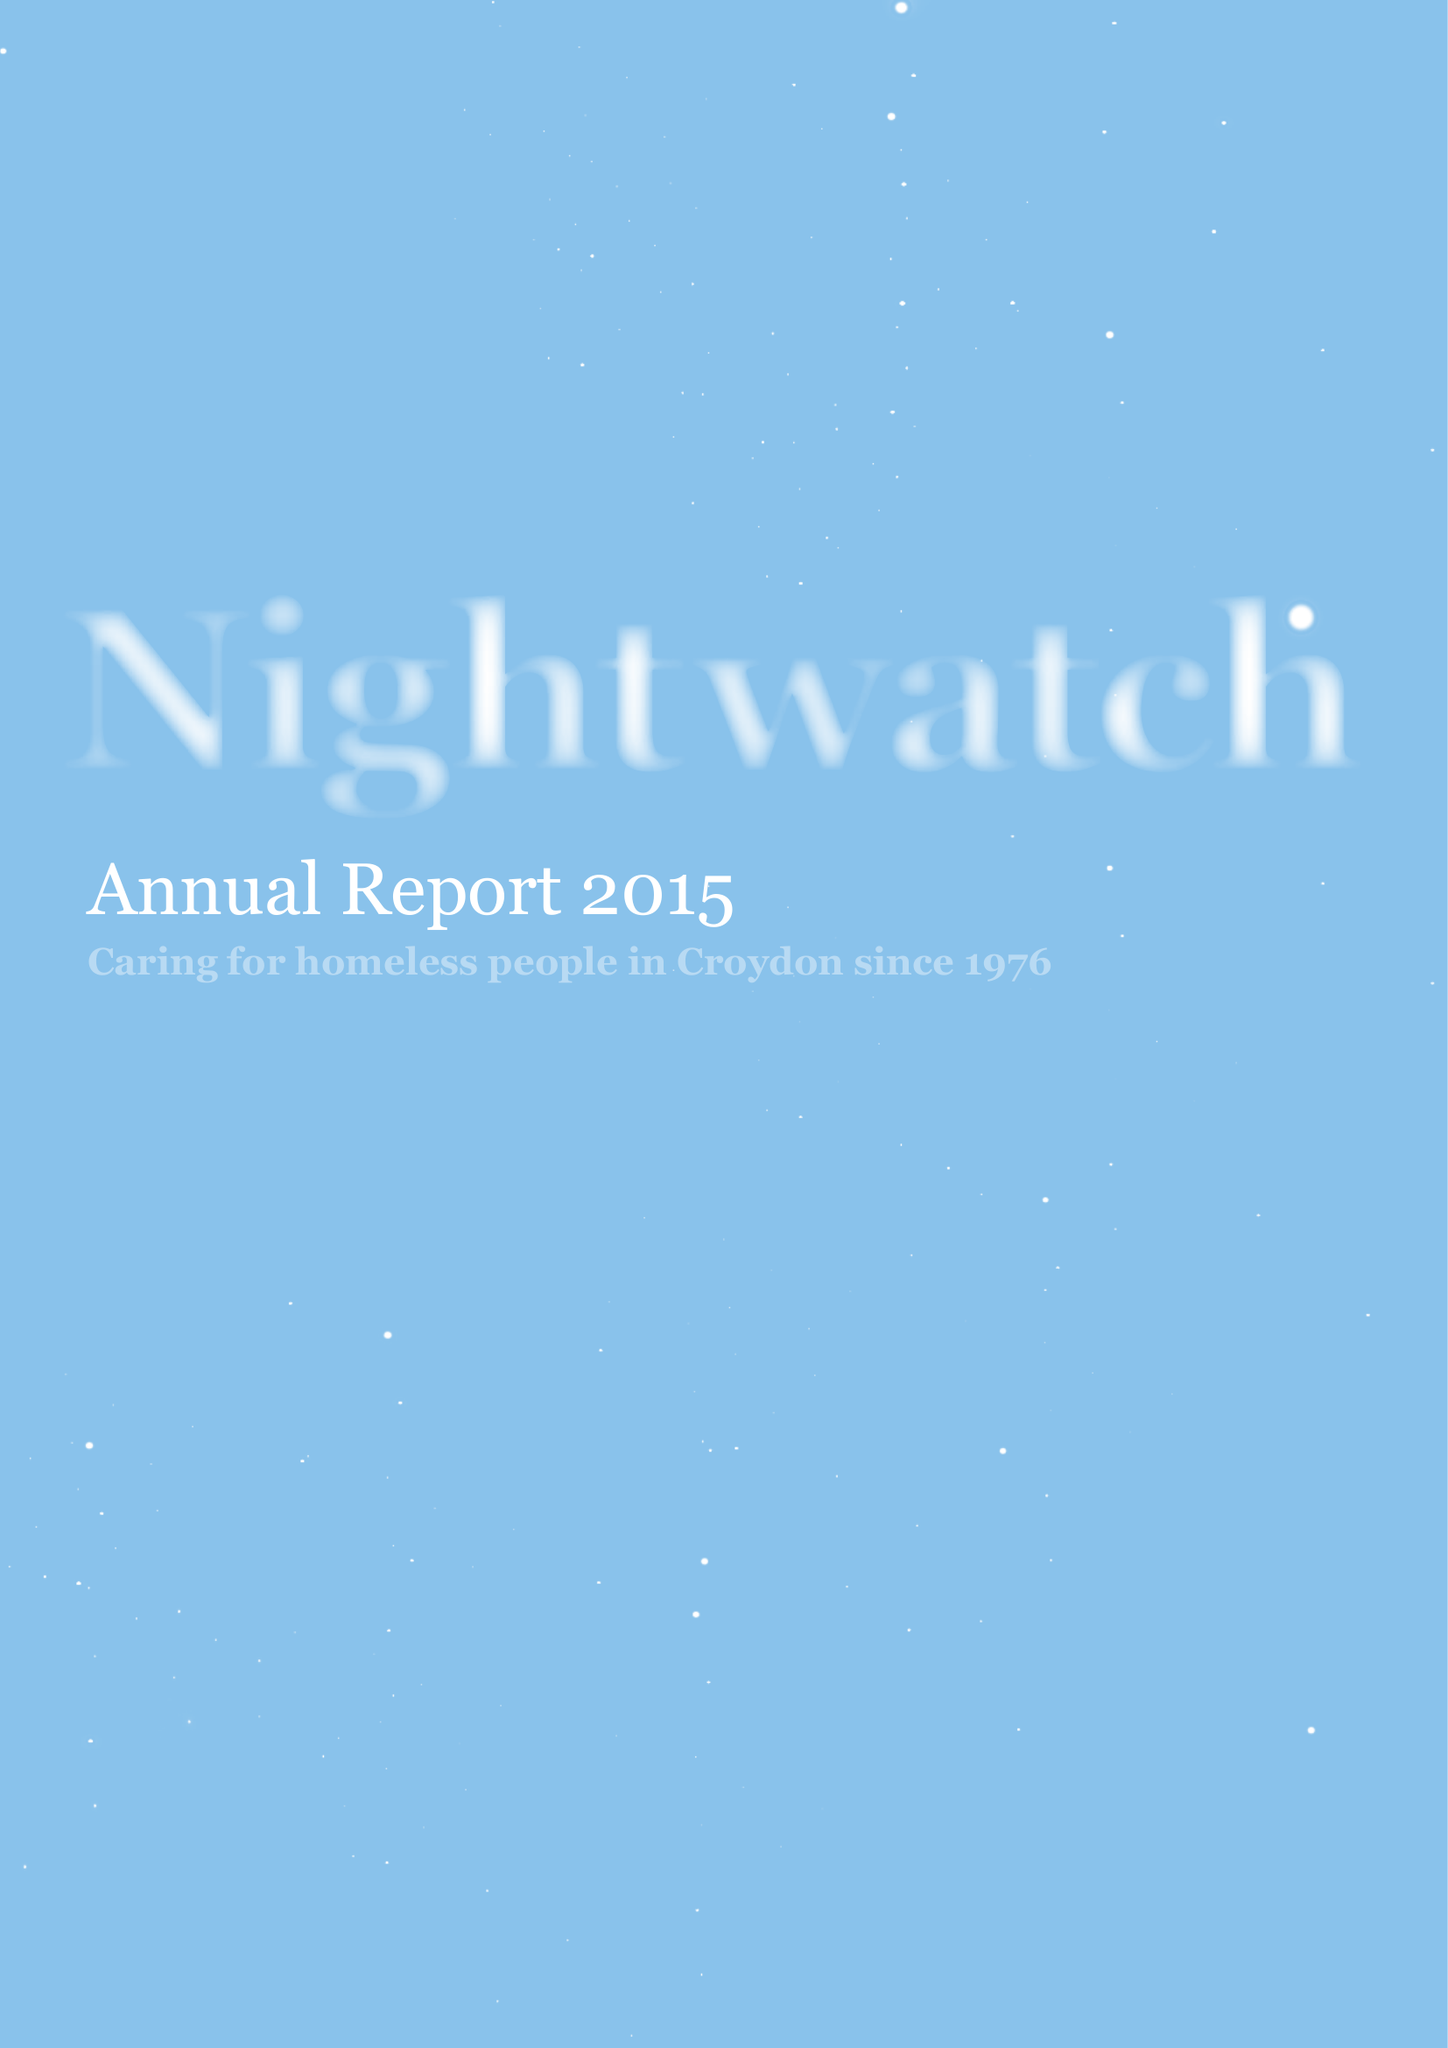What is the value for the income_annually_in_british_pounds?
Answer the question using a single word or phrase. 41210.00 